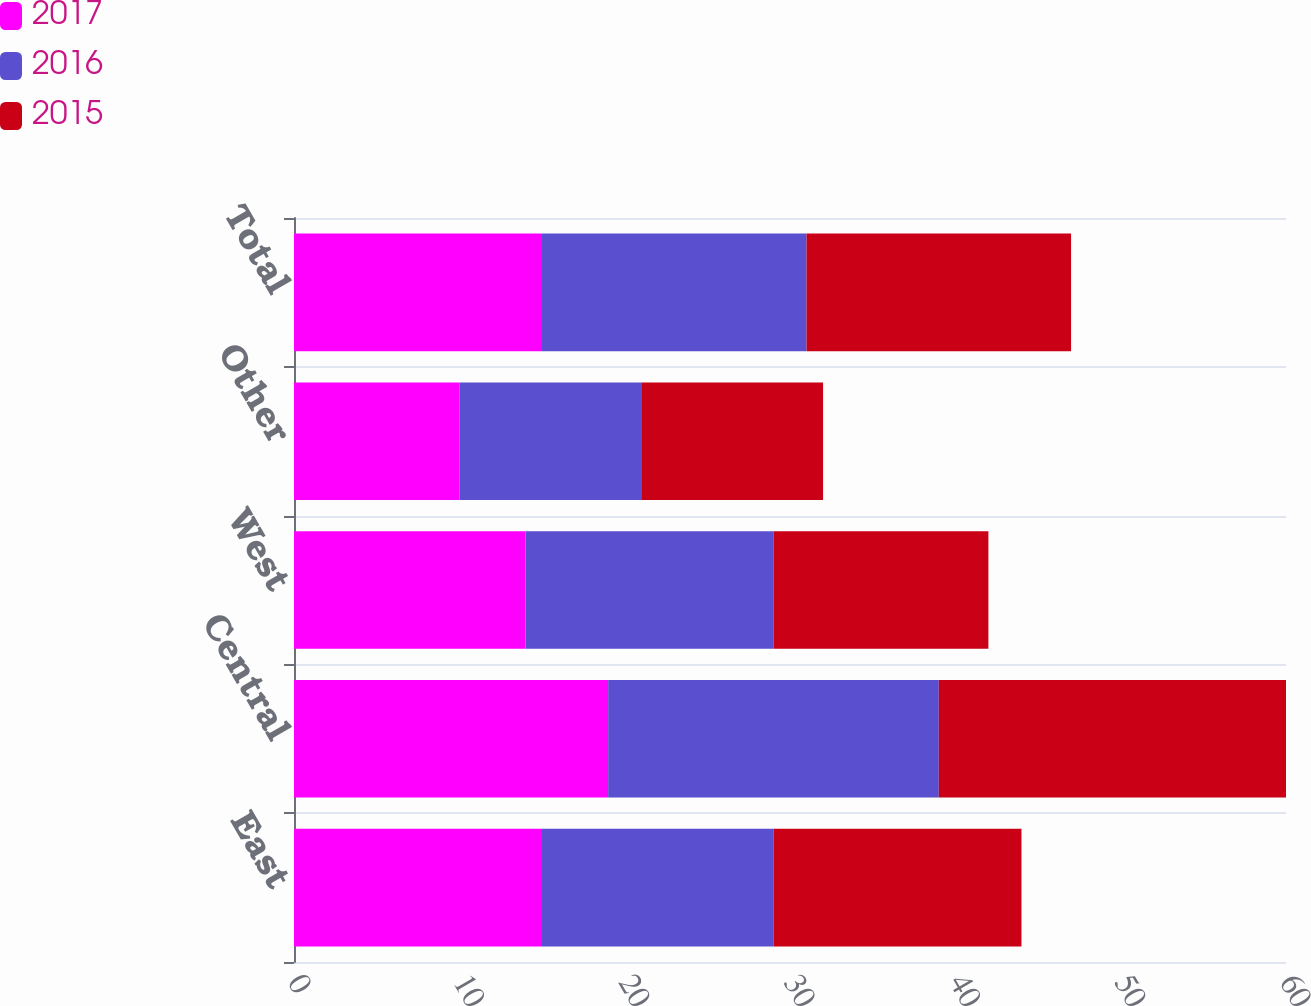Convert chart to OTSL. <chart><loc_0><loc_0><loc_500><loc_500><stacked_bar_chart><ecel><fcel>East<fcel>Central<fcel>West<fcel>Other<fcel>Total<nl><fcel>2017<fcel>15<fcel>19<fcel>14<fcel>10<fcel>15<nl><fcel>2016<fcel>14<fcel>20<fcel>15<fcel>11<fcel>16<nl><fcel>2015<fcel>15<fcel>21<fcel>13<fcel>11<fcel>16<nl></chart> 